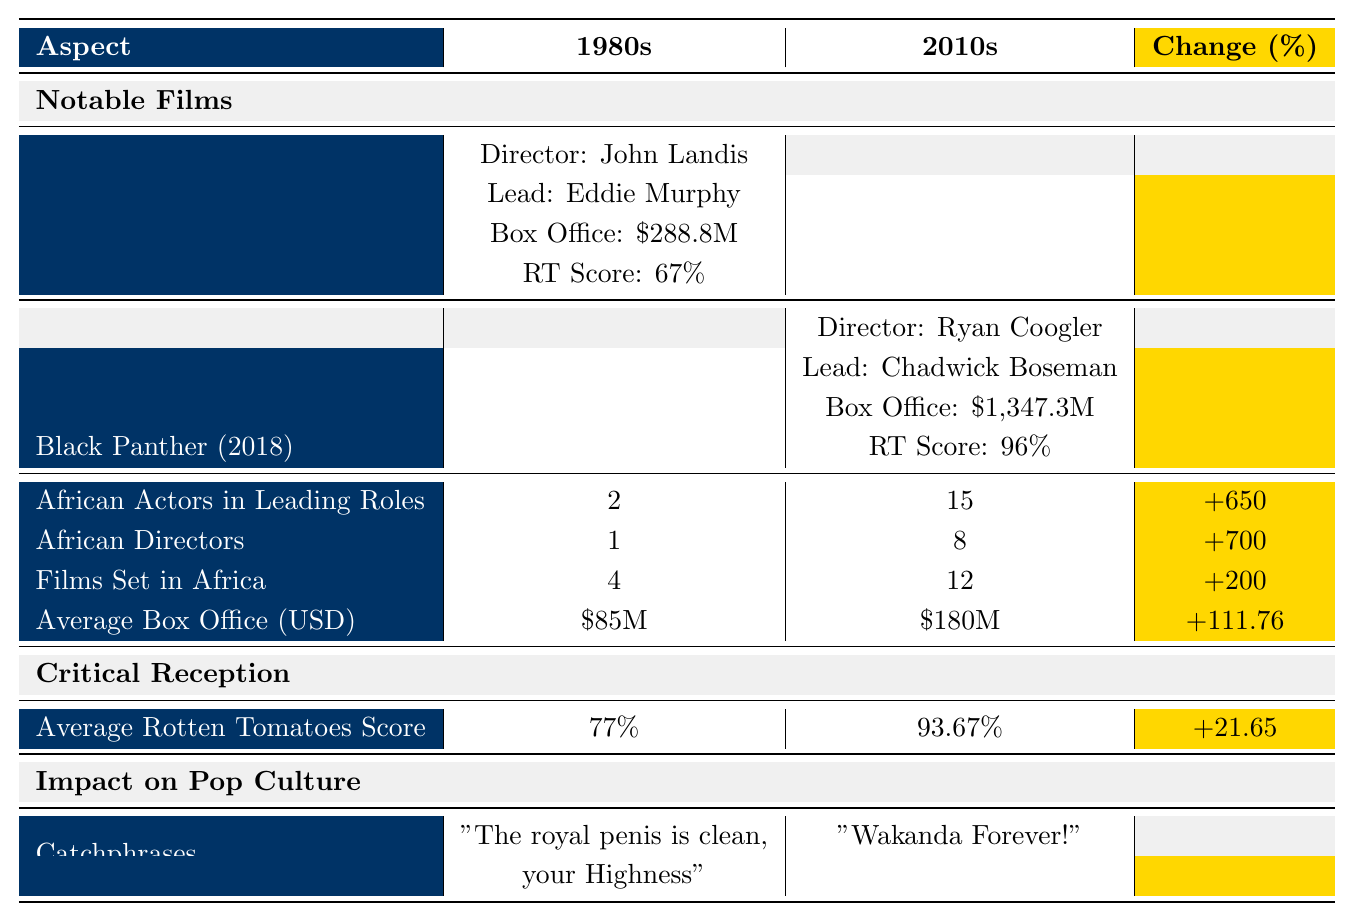What were the notable films in the 1980s? The notable films listed under the 1980s section are "Coming to America (1988)", "The Color Purple (1985)", and "A Dry White Season (1989)".
Answer: "Coming to America", "The Color Purple", "A Dry White Season" How many African directors were there in the 2010s? The table states that there were 8 African directors in the 2010s section.
Answer: 8 What is the increase in the number of African actors in leading roles from the 1980s to the 2010s? The number of African actors in leading roles in the 1980s was 2, and in the 2010s, it was 15. The increase is calculated as (15 - 2) = 13, which corresponds to a 650% increase.
Answer: 650% Which film had the highest box office gross in the 2010s? According to the table, "Black Panther (2018)" had the highest box office gross at $1,347.3 million.
Answer: Black Panther (2018) What was the average box office for the films in the 1980s? The average box office for the films in the 1980s is stated as $85 million in the table.
Answer: $85 million Did the average Rotten Tomatoes score improve from the 1980s to the 2010s? Yes, the average Rotten Tomatoes score improved from 77% in the 1980s to 93.67% in the 2010s, indicating an improvement in critical reception.
Answer: Yes What was the percentage change in films set in Africa from the 1980s to the 2010s? In the 1980s, there were 4 films set in Africa, and in the 2010s, there were 12. The percentage change is calculated as ((12 - 4) / 4) * 100 = 200%.
Answer: 200% How many catchphrases were mentioned for the 2010s and what is one of them? The 2010s list two catchphrases, one of which is "Wakanda Forever!".
Answer: "Wakanda Forever!" What is the difference in average Rotten Tomatoes scores between the two decades? The average Rotten Tomatoes score for the 1980s is 77%, and for the 2010s, it is 93.67%. The difference is 93.67% - 77% = 16.67%.
Answer: 16.67% Which decade had the higher average box office revenue, and by how much? The 2010s had an average box office of $180 million compared to $85 million in the 1980s. The difference is $180 million - $85 million = $95 million.
Answer: 2010s had higher by $95 million 